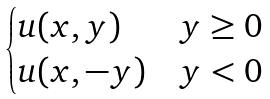<formula> <loc_0><loc_0><loc_500><loc_500>\begin{cases} u ( x , y ) & y \geq 0 \\ u ( x , - y ) & y < 0 \end{cases}</formula> 